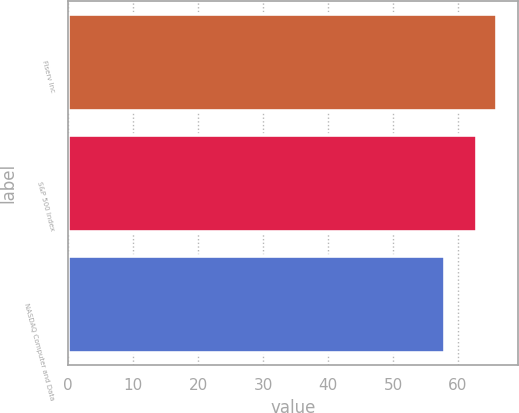Convert chart to OTSL. <chart><loc_0><loc_0><loc_500><loc_500><bar_chart><fcel>Fiserv Inc<fcel>S&P 500 Index<fcel>NASDAQ Computer and Data<nl><fcel>66<fcel>63<fcel>58<nl></chart> 